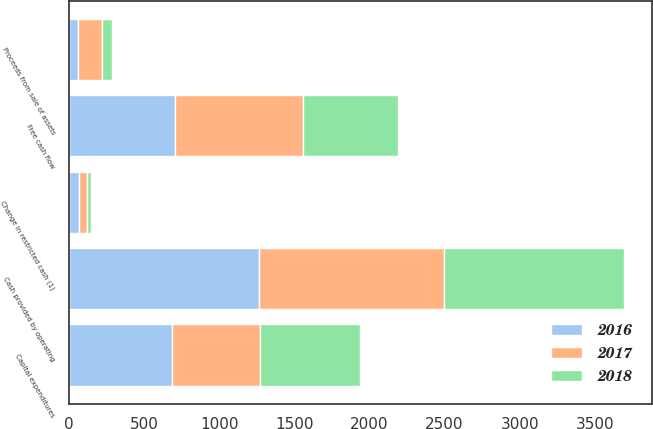<chart> <loc_0><loc_0><loc_500><loc_500><stacked_bar_chart><ecel><fcel>Cash provided by operating<fcel>Capital expenditures<fcel>Proceeds from sale of assets<fcel>Change in restricted cash (1)<fcel>Free cash flow<nl><fcel>2017<fcel>1229<fcel>590<fcel>160<fcel>54<fcel>853<nl><fcel>2016<fcel>1264<fcel>684<fcel>61<fcel>66<fcel>707<nl><fcel>2018<fcel>1203<fcel>660<fcel>63<fcel>24<fcel>630<nl></chart> 